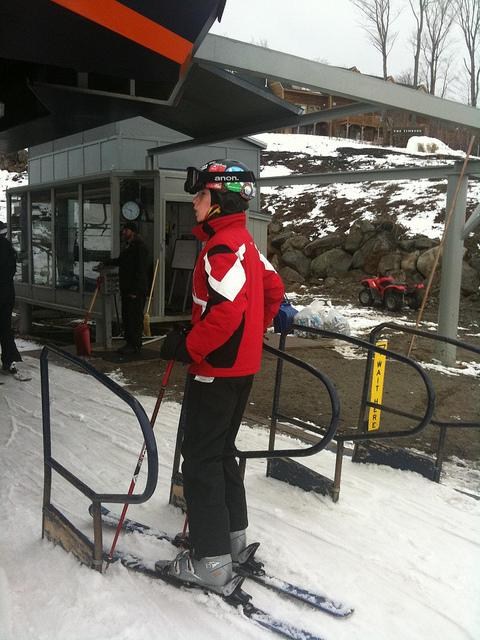What are the bars for?

Choices:
A) holds poles
B) holds skis
C) stand waiting
D) holds clothing stand waiting 